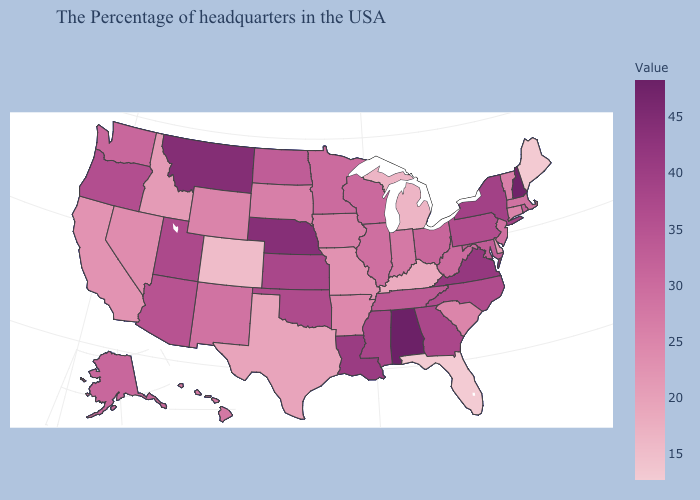Among the states that border Nebraska , which have the highest value?
Quick response, please. Kansas. Which states have the highest value in the USA?
Answer briefly. Alabama. Which states hav the highest value in the West?
Be succinct. Montana. Which states hav the highest value in the MidWest?
Concise answer only. Nebraska. Among the states that border Rhode Island , does Connecticut have the lowest value?
Short answer required. Yes. 